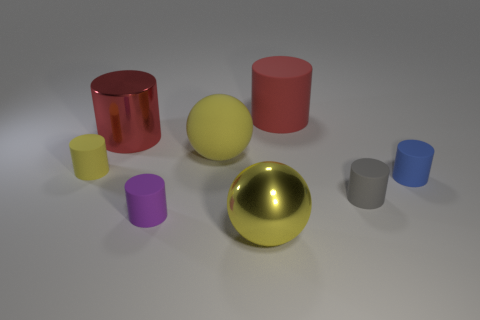There is a yellow thing to the left of the big shiny cylinder; what material is it?
Your answer should be compact. Rubber. What material is the purple thing that is the same shape as the red rubber object?
Give a very brief answer. Rubber. Is there a large red shiny cylinder in front of the large sphere that is behind the small blue cylinder?
Offer a very short reply. No. Is the small purple object the same shape as the blue object?
Give a very brief answer. Yes. There is a purple thing that is the same material as the tiny gray cylinder; what shape is it?
Offer a very short reply. Cylinder. Do the red object that is on the right side of the tiny purple thing and the ball that is in front of the tiny blue matte object have the same size?
Ensure brevity in your answer.  Yes. Are there more small purple things in front of the yellow metallic ball than red metal cylinders on the right side of the small gray thing?
Offer a very short reply. No. How many other objects are the same color as the large rubber cylinder?
Make the answer very short. 1. Does the big matte ball have the same color as the tiny cylinder in front of the gray matte thing?
Your answer should be very brief. No. There is a tiny matte cylinder right of the small gray rubber thing; what number of cylinders are right of it?
Offer a very short reply. 0. 